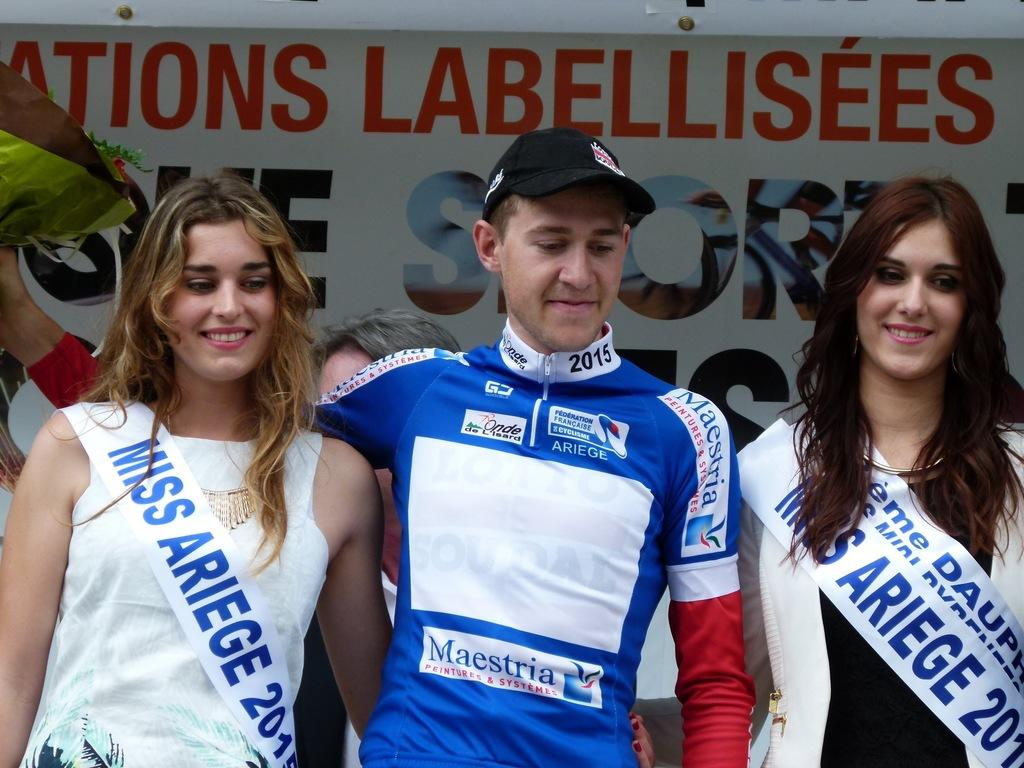<image>
Relay a brief, clear account of the picture shown. a man standing between women with Miss Ariege sashes 